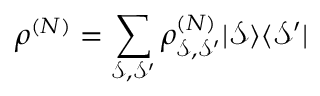Convert formula to latex. <formula><loc_0><loc_0><loc_500><loc_500>\rho ^ { ( N ) } = \sum _ { \mathcal { S } , \mathcal { S } ^ { \prime } } \rho _ { \mathcal { S } , \mathcal { S } ^ { \prime } } ^ { ( N ) } | \mathcal { S } \rangle \langle \mathcal { S } ^ { \prime } |</formula> 